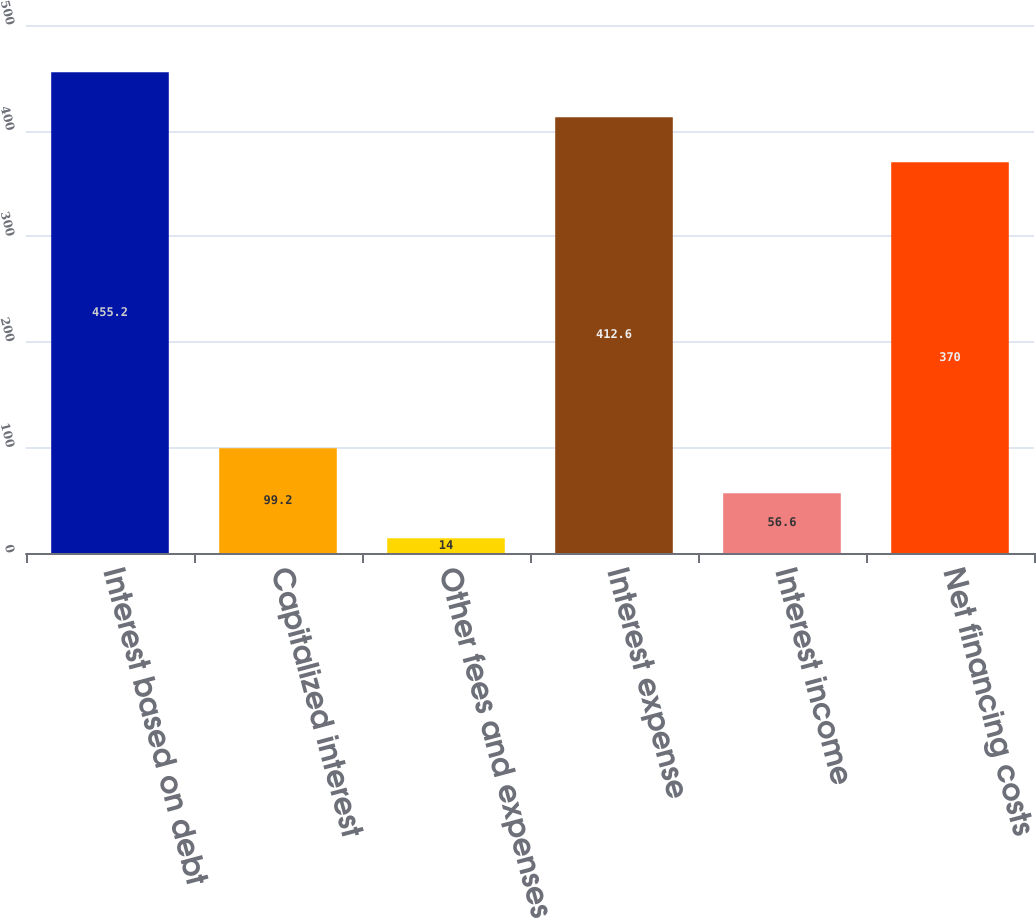Convert chart. <chart><loc_0><loc_0><loc_500><loc_500><bar_chart><fcel>Interest based on debt<fcel>Capitalized interest<fcel>Other fees and expenses<fcel>Interest expense<fcel>Interest income<fcel>Net financing costs<nl><fcel>455.2<fcel>99.2<fcel>14<fcel>412.6<fcel>56.6<fcel>370<nl></chart> 